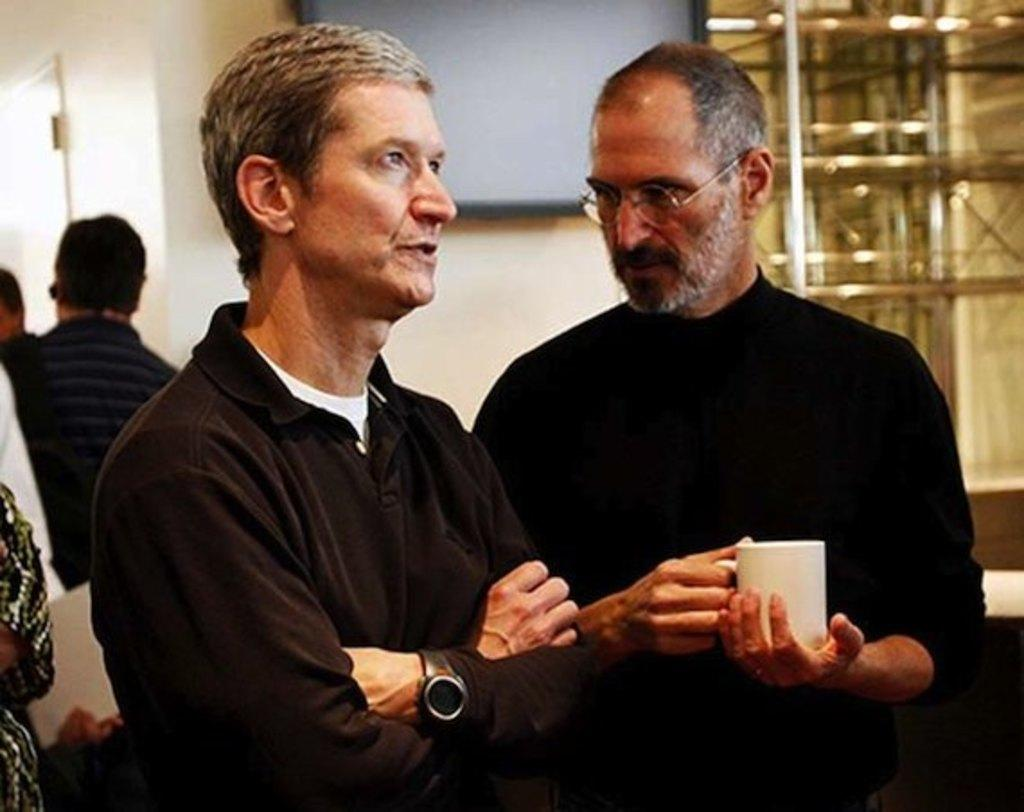How many people are in the image? There are people in the image, but the exact number is not specified. What is one person doing in the image? One person is looking at another person. What is the person looking at holding? The person looking is holding a mug. Can you describe the background of the image? The background of the image is blurred, and there is a board and a wall visible. What type of pollution can be seen in the image? There is no mention of pollution in the image, as the focus is on the people and their interactions. 